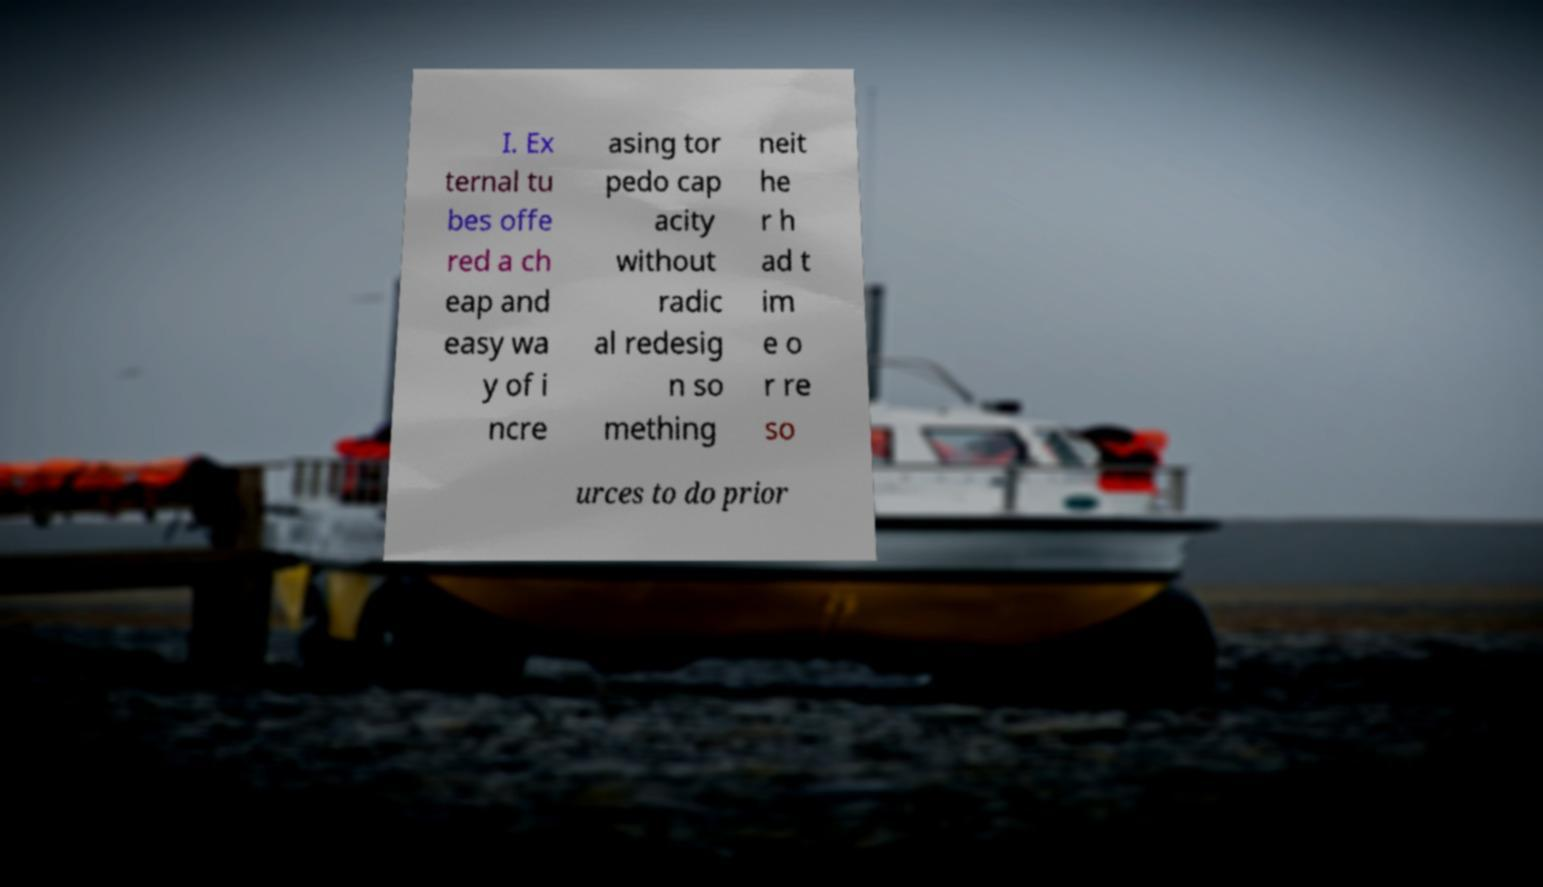What messages or text are displayed in this image? I need them in a readable, typed format. I. Ex ternal tu bes offe red a ch eap and easy wa y of i ncre asing tor pedo cap acity without radic al redesig n so mething neit he r h ad t im e o r re so urces to do prior 